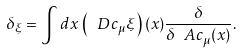<formula> <loc_0><loc_0><loc_500><loc_500>\delta _ { \xi } = \int d x \, \left ( \ D c _ { \mu } \xi \right ) ( x ) \frac { \delta } { \delta \ A c _ { \mu } ( x ) } .</formula> 